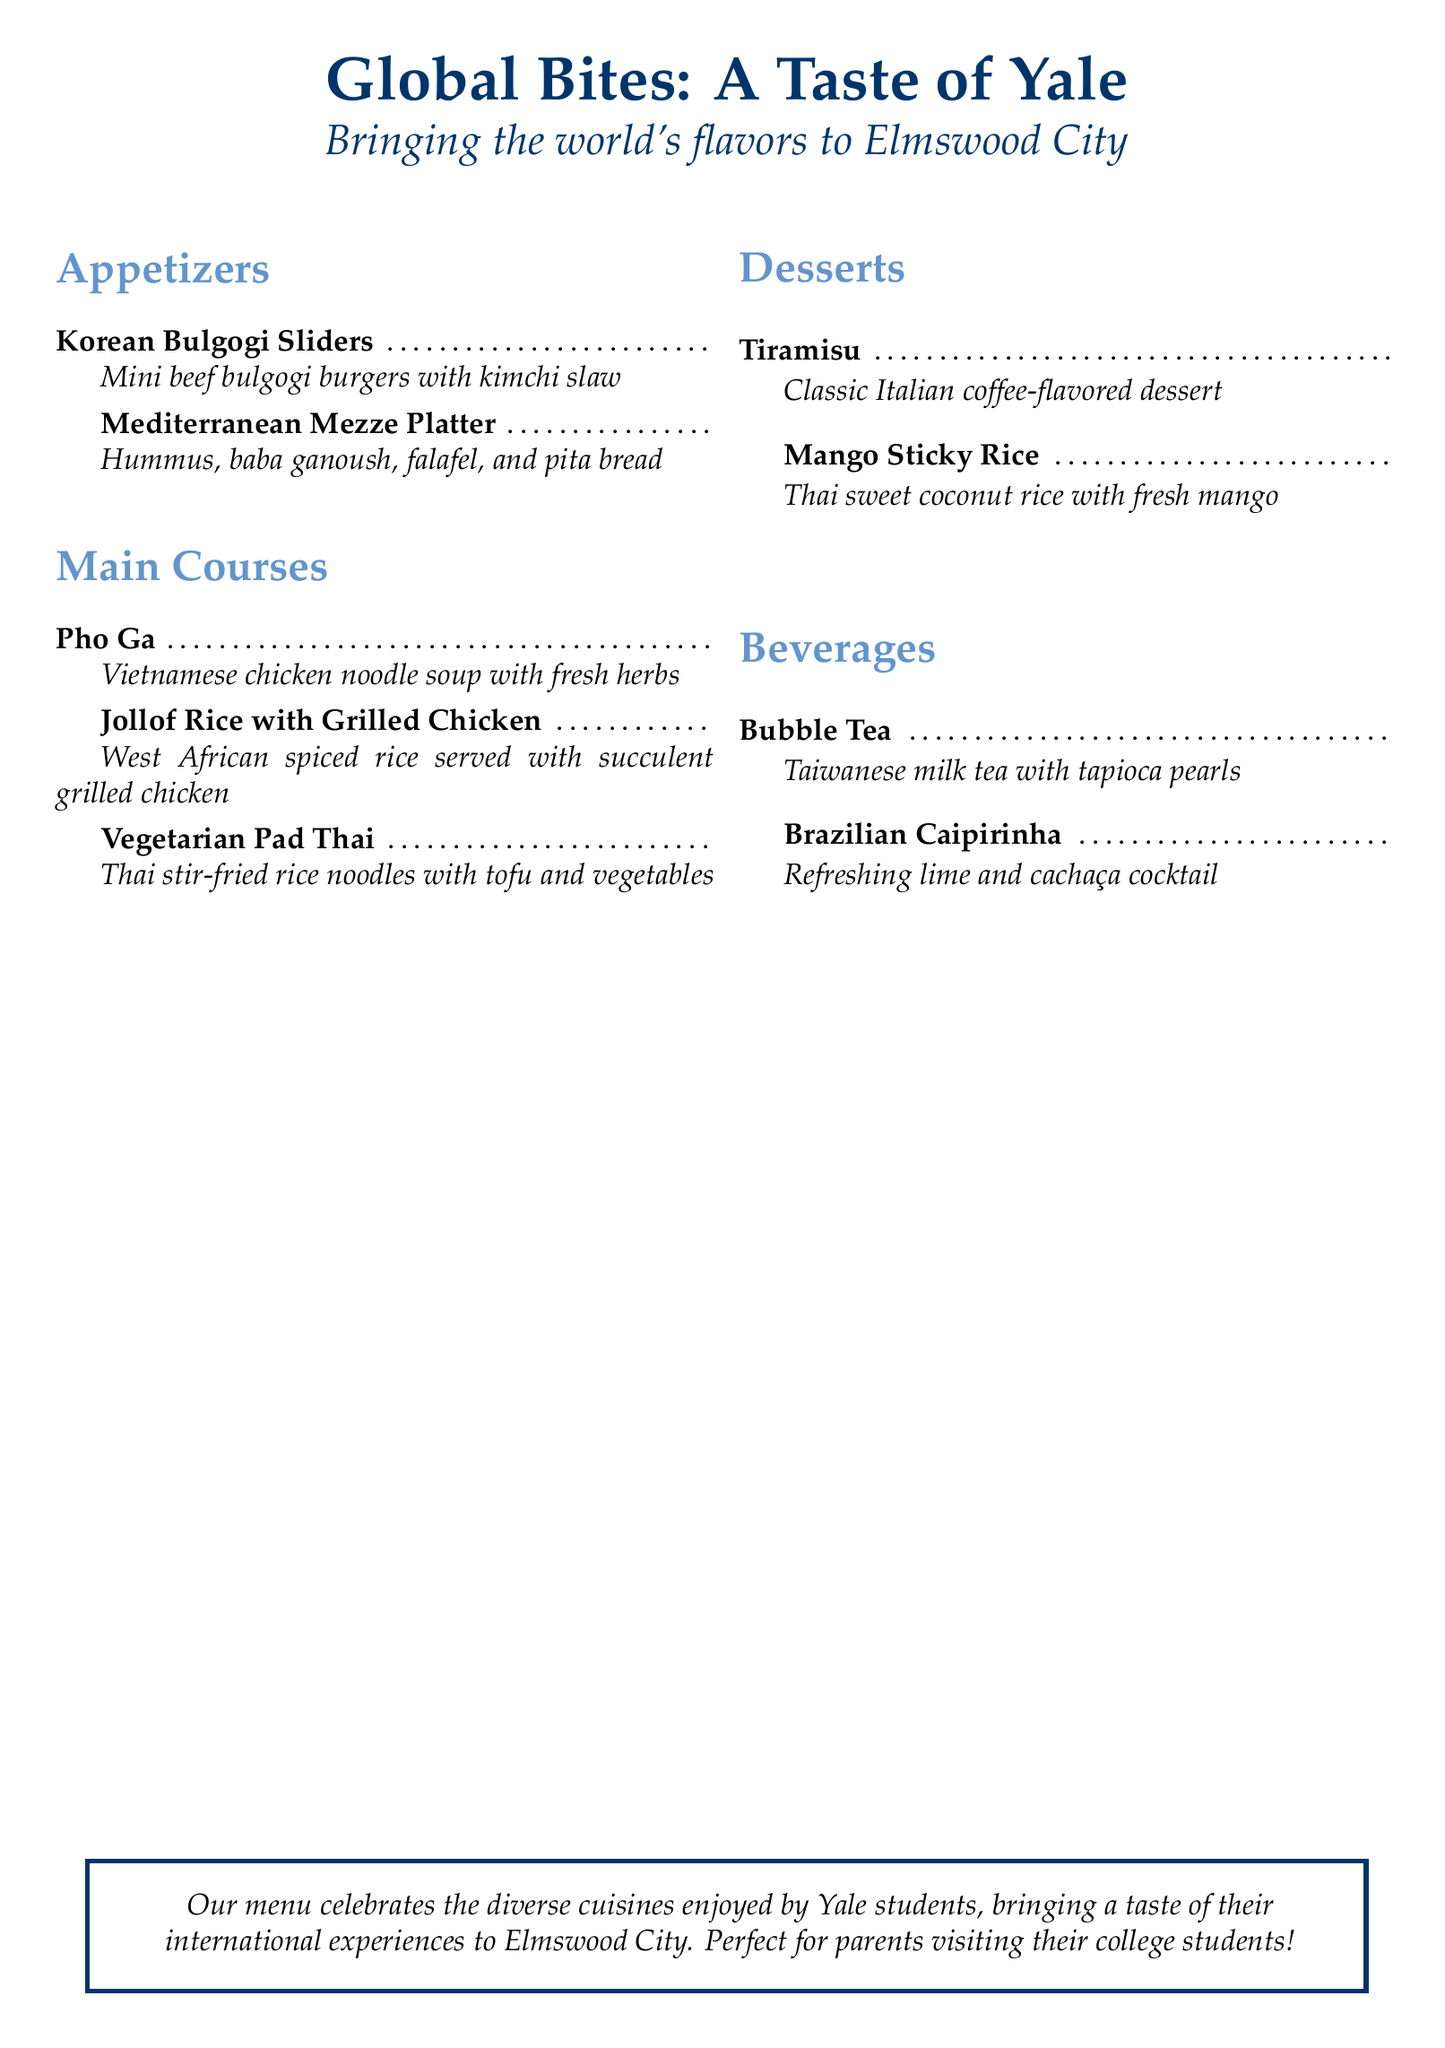What is the name of the menu? The name of the menu is prominently displayed at the top of the document.
Answer: Global Bites: A Taste of Yale How many appetizer items are listed? The menu shows two sections with items listed, and the "Appetizers" section contains a specific number of items.
Answer: 2 What is the first main course item? The first item listed under the "Main Courses" section provides a direct answer.
Answer: Pho Ga Which dessert is made with coconut rice? The dessert with, coconut rice is specified in the "Desserts" section of the menu.
Answer: Mango Sticky Rice What type of tea is featured in the beverages? The beverages section includes a specific type of tea, which is labeled clearly.
Answer: Bubble Tea What is one ingredient in the Mediterranean Mezze Platter? The Mediterranean Mezze Platter lists ingredients directly associated with it.
Answer: Hummus How is the Jollof Rice served? The description for Jollof Rice includes details on how it is served to provide clarity.
Answer: With succulent grilled chicken What is the color of the document's theme? The theme color can be inferred from the color codes used in the document.
Answer: Yale blue 